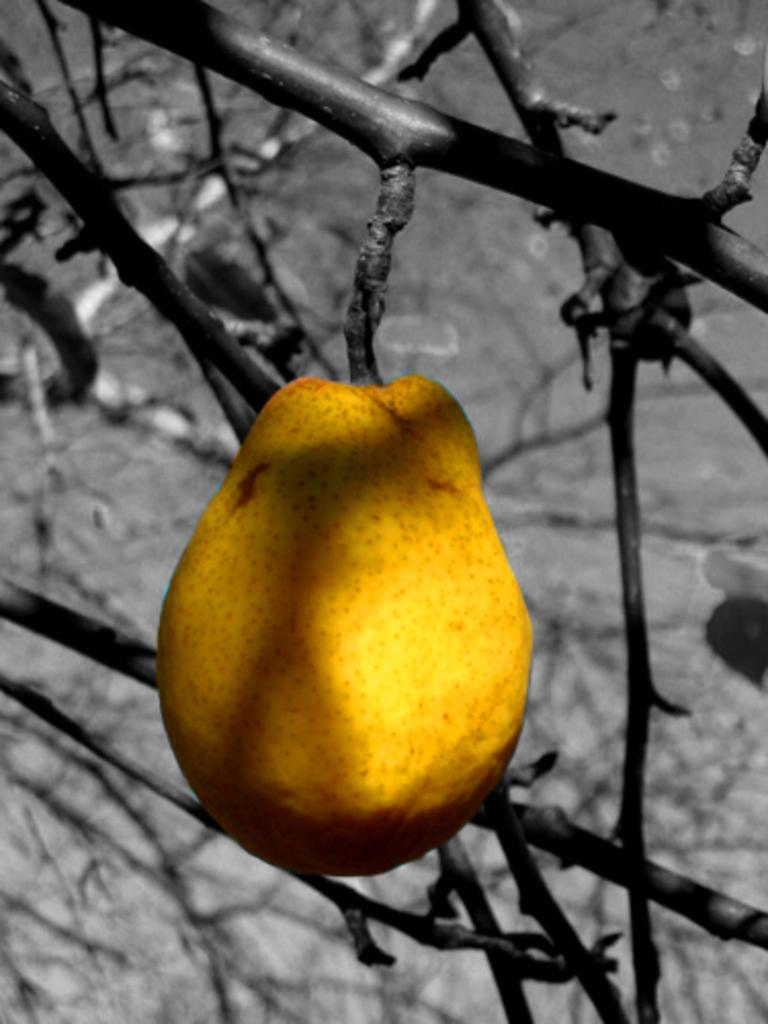What type of fruit is visible in the image? There is a yellow colored fruit in the image. How is the fruit positioned in the image? The fruit is hung on a branch of a tree. What is the color scheme of the background in the image? The background of the image is black and white in color. What advertisement can be seen on the fruit in the image? There is no advertisement present on the fruit in the image. What cause does the fruit represent in the image? There is no cause represented by the fruit in the image. 